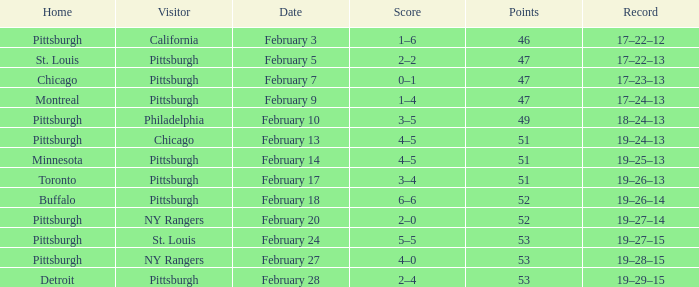Which Score has a Visitor of ny rangers, and a Record of 19–28–15? 4–0. 